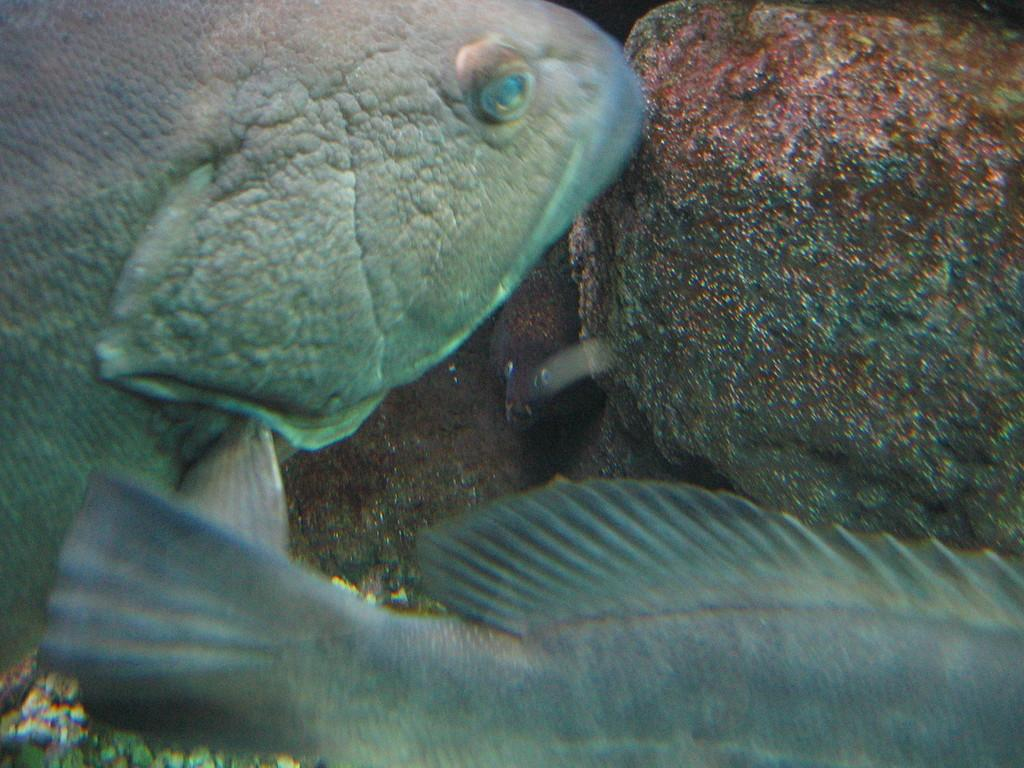What type of natural feature is present in the image? There is a water body in the image. What can be found living in the water body? There are fishes in the water body. Are there any other objects or features visible in the image? Yes, there are rocks visible in the image. What type of jelly can be seen floating in the water body in the image? There is no jelly present in the image; it features a water body with fishes and rocks. Is there a cellar visible in the image? There is no cellar present in the image; it features a water body with fishes and rocks. 